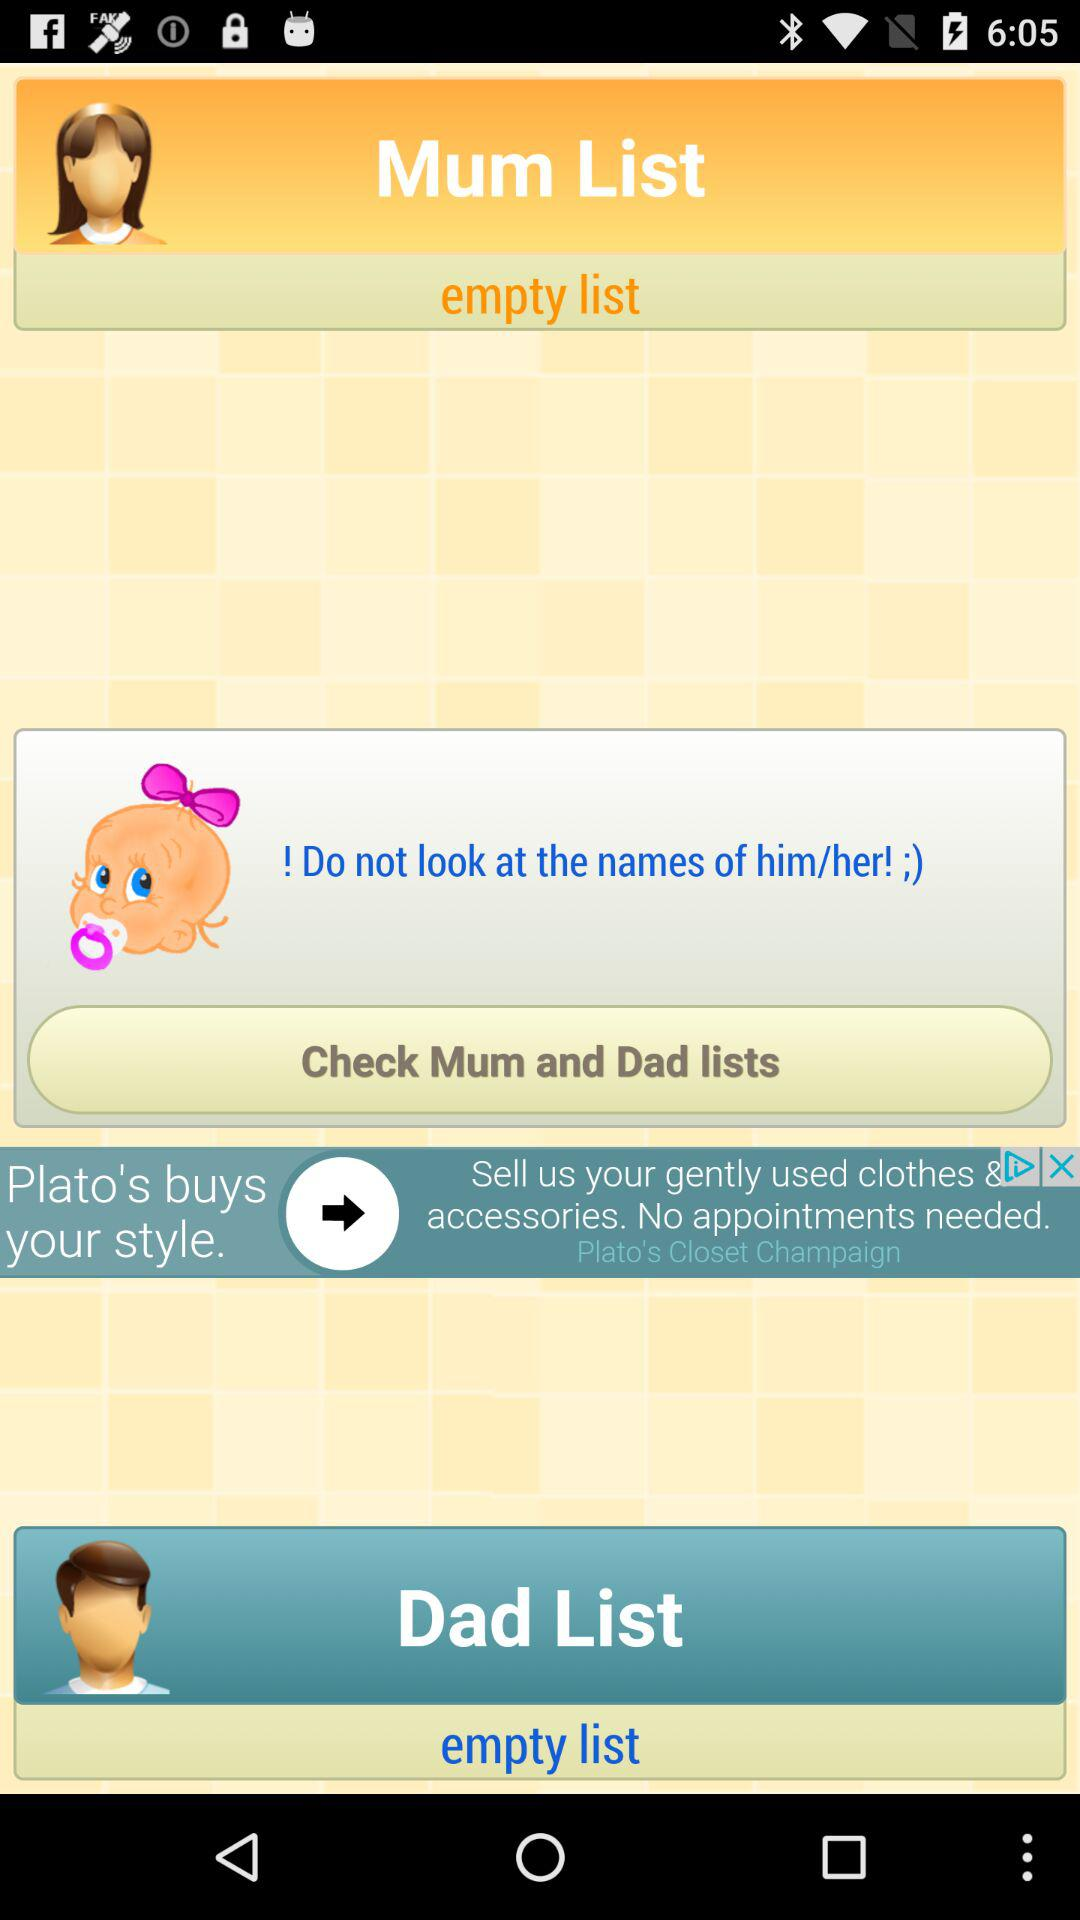Is there any item in the "Mum List"? The "Mum List" is empty. 